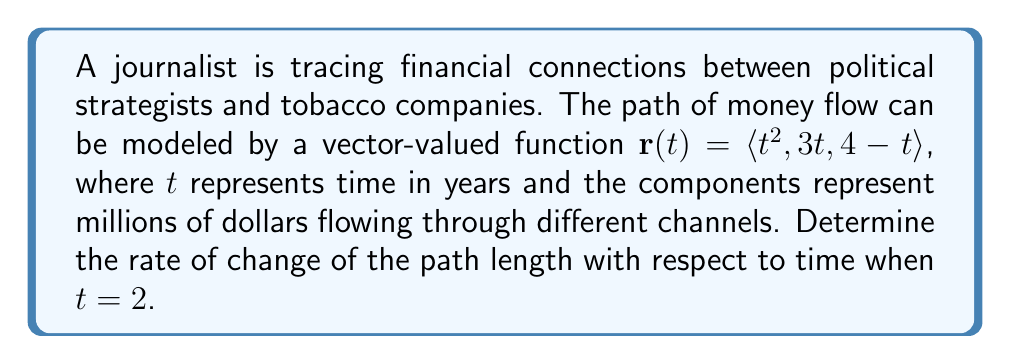Show me your answer to this math problem. To solve this problem, we need to follow these steps:

1) The path length $s$ as a function of $t$ is given by:

   $$s(t) = \int_0^t |\mathbf{r}'(u)| du$$

2) We need to find $\mathbf{r}'(t)$:
   
   $$\mathbf{r}'(t) = \langle 2t, 3, -1 \rangle$$

3) Now, we calculate $|\mathbf{r}'(t)|$:

   $$|\mathbf{r}'(t)| = \sqrt{(2t)^2 + 3^2 + (-1)^2} = \sqrt{4t^2 + 10}$$

4) The rate of change of path length with respect to time is given by $\frac{ds}{dt}$, which is equal to $|\mathbf{r}'(t)|$:

   $$\frac{ds}{dt} = |\mathbf{r}'(t)| = \sqrt{4t^2 + 10}$$

5) We need to evaluate this at $t=2$:

   $$\frac{ds}{dt}\bigg|_{t=2} = \sqrt{4(2)^2 + 10} = \sqrt{26}$$

Therefore, the rate of change of the path length with respect to time when $t=2$ is $\sqrt{26}$ million dollars per year.
Answer: $\sqrt{26}$ million dollars per year 